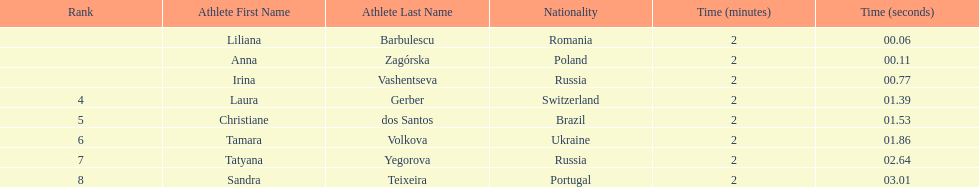What was the time difference between the first place finisher and the eighth place finisher? 2.95. 